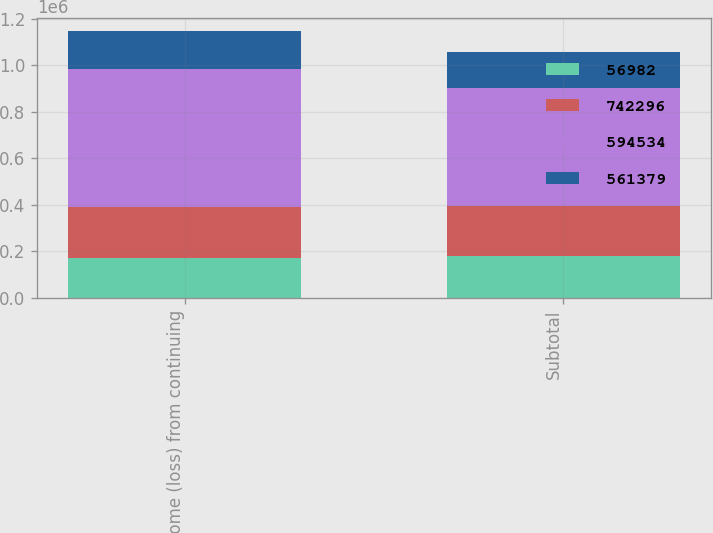Convert chart. <chart><loc_0><loc_0><loc_500><loc_500><stacked_bar_chart><ecel><fcel>Income (loss) from continuing<fcel>Subtotal<nl><fcel>56982<fcel>172270<fcel>178798<nl><fcel>742296<fcel>216257<fcel>215377<nl><fcel>594534<fcel>594534<fcel>508616<nl><fcel>561379<fcel>162589<fcel>154355<nl></chart> 